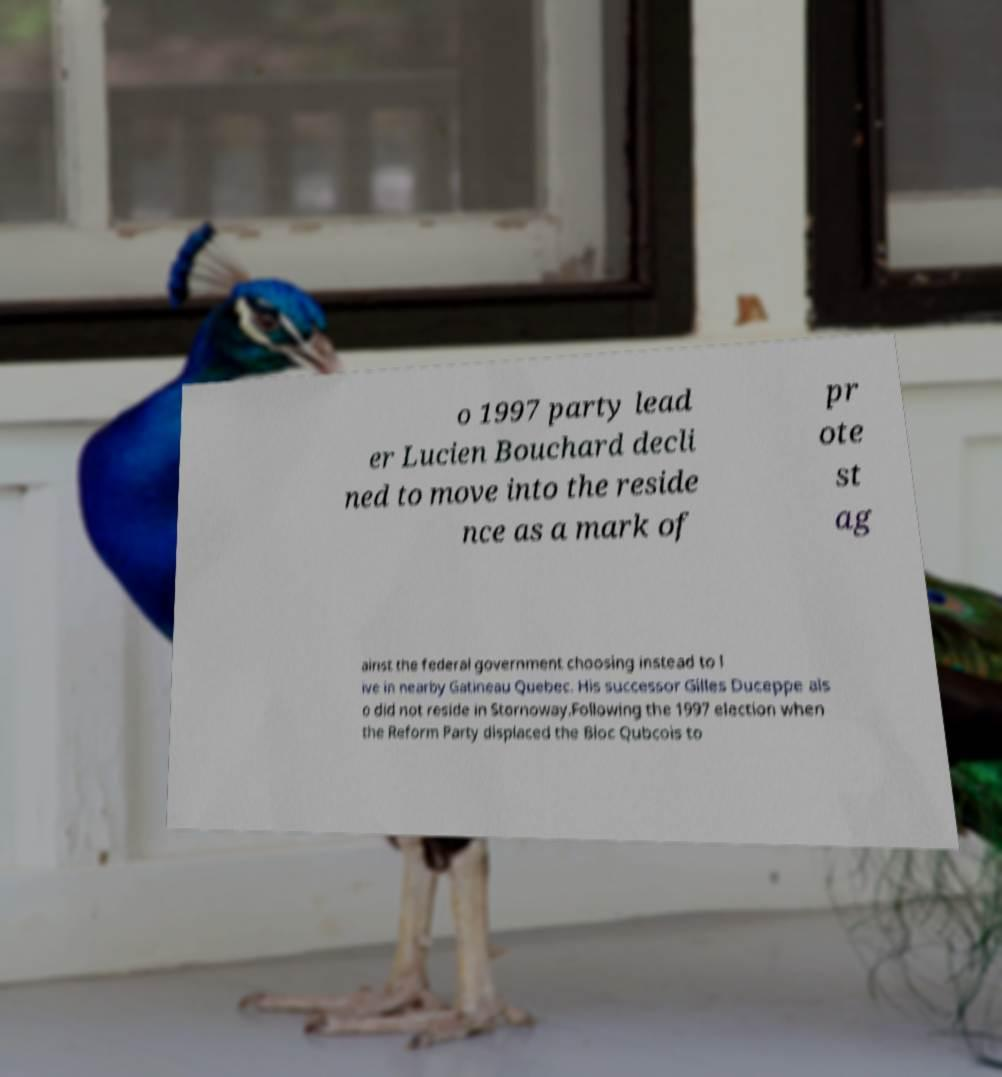Please read and relay the text visible in this image. What does it say? o 1997 party lead er Lucien Bouchard decli ned to move into the reside nce as a mark of pr ote st ag ainst the federal government choosing instead to l ive in nearby Gatineau Quebec. His successor Gilles Duceppe als o did not reside in Stornoway.Following the 1997 election when the Reform Party displaced the Bloc Qubcois to 